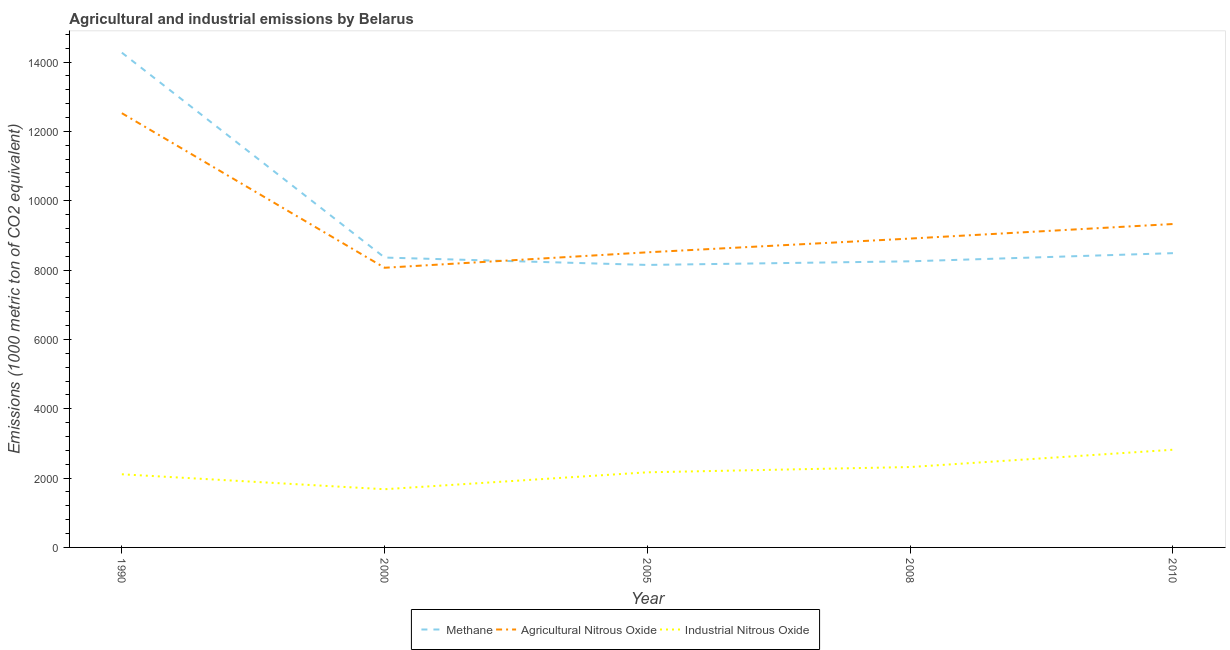What is the amount of industrial nitrous oxide emissions in 2010?
Your answer should be very brief. 2817.5. Across all years, what is the maximum amount of methane emissions?
Offer a terse response. 1.43e+04. Across all years, what is the minimum amount of agricultural nitrous oxide emissions?
Provide a succinct answer. 8066.2. In which year was the amount of methane emissions maximum?
Give a very brief answer. 1990. In which year was the amount of industrial nitrous oxide emissions minimum?
Your answer should be very brief. 2000. What is the total amount of methane emissions in the graph?
Your response must be concise. 4.75e+04. What is the difference between the amount of industrial nitrous oxide emissions in 1990 and that in 2010?
Your answer should be compact. -707.9. What is the difference between the amount of industrial nitrous oxide emissions in 2010 and the amount of agricultural nitrous oxide emissions in 2008?
Ensure brevity in your answer.  -6090.9. What is the average amount of agricultural nitrous oxide emissions per year?
Your answer should be very brief. 9467.8. In the year 2010, what is the difference between the amount of industrial nitrous oxide emissions and amount of agricultural nitrous oxide emissions?
Provide a succinct answer. -6510.4. In how many years, is the amount of methane emissions greater than 12800 metric ton?
Your response must be concise. 1. What is the ratio of the amount of methane emissions in 1990 to that in 2000?
Provide a succinct answer. 1.71. What is the difference between the highest and the second highest amount of agricultural nitrous oxide emissions?
Make the answer very short. 3196.7. What is the difference between the highest and the lowest amount of agricultural nitrous oxide emissions?
Make the answer very short. 4458.4. Is it the case that in every year, the sum of the amount of methane emissions and amount of agricultural nitrous oxide emissions is greater than the amount of industrial nitrous oxide emissions?
Offer a terse response. Yes. Does the amount of methane emissions monotonically increase over the years?
Offer a terse response. No. How many lines are there?
Your answer should be compact. 3. How many years are there in the graph?
Give a very brief answer. 5. What is the difference between two consecutive major ticks on the Y-axis?
Provide a short and direct response. 2000. Are the values on the major ticks of Y-axis written in scientific E-notation?
Your response must be concise. No. Does the graph contain any zero values?
Your response must be concise. No. How many legend labels are there?
Provide a short and direct response. 3. How are the legend labels stacked?
Give a very brief answer. Horizontal. What is the title of the graph?
Keep it short and to the point. Agricultural and industrial emissions by Belarus. Does "Textiles and clothing" appear as one of the legend labels in the graph?
Make the answer very short. No. What is the label or title of the X-axis?
Keep it short and to the point. Year. What is the label or title of the Y-axis?
Your answer should be compact. Emissions (1000 metric ton of CO2 equivalent). What is the Emissions (1000 metric ton of CO2 equivalent) of Methane in 1990?
Make the answer very short. 1.43e+04. What is the Emissions (1000 metric ton of CO2 equivalent) in Agricultural Nitrous Oxide in 1990?
Keep it short and to the point. 1.25e+04. What is the Emissions (1000 metric ton of CO2 equivalent) of Industrial Nitrous Oxide in 1990?
Give a very brief answer. 2109.6. What is the Emissions (1000 metric ton of CO2 equivalent) of Methane in 2000?
Provide a short and direct response. 8360.4. What is the Emissions (1000 metric ton of CO2 equivalent) in Agricultural Nitrous Oxide in 2000?
Ensure brevity in your answer.  8066.2. What is the Emissions (1000 metric ton of CO2 equivalent) in Industrial Nitrous Oxide in 2000?
Ensure brevity in your answer.  1678.6. What is the Emissions (1000 metric ton of CO2 equivalent) in Methane in 2005?
Ensure brevity in your answer.  8147.7. What is the Emissions (1000 metric ton of CO2 equivalent) of Agricultural Nitrous Oxide in 2005?
Ensure brevity in your answer.  8511.9. What is the Emissions (1000 metric ton of CO2 equivalent) in Industrial Nitrous Oxide in 2005?
Give a very brief answer. 2166.7. What is the Emissions (1000 metric ton of CO2 equivalent) of Methane in 2008?
Give a very brief answer. 8252. What is the Emissions (1000 metric ton of CO2 equivalent) of Agricultural Nitrous Oxide in 2008?
Keep it short and to the point. 8908.4. What is the Emissions (1000 metric ton of CO2 equivalent) of Industrial Nitrous Oxide in 2008?
Your response must be concise. 2318.7. What is the Emissions (1000 metric ton of CO2 equivalent) of Methane in 2010?
Offer a terse response. 8487.5. What is the Emissions (1000 metric ton of CO2 equivalent) of Agricultural Nitrous Oxide in 2010?
Offer a very short reply. 9327.9. What is the Emissions (1000 metric ton of CO2 equivalent) of Industrial Nitrous Oxide in 2010?
Provide a short and direct response. 2817.5. Across all years, what is the maximum Emissions (1000 metric ton of CO2 equivalent) of Methane?
Your answer should be compact. 1.43e+04. Across all years, what is the maximum Emissions (1000 metric ton of CO2 equivalent) of Agricultural Nitrous Oxide?
Make the answer very short. 1.25e+04. Across all years, what is the maximum Emissions (1000 metric ton of CO2 equivalent) in Industrial Nitrous Oxide?
Offer a terse response. 2817.5. Across all years, what is the minimum Emissions (1000 metric ton of CO2 equivalent) in Methane?
Offer a terse response. 8147.7. Across all years, what is the minimum Emissions (1000 metric ton of CO2 equivalent) of Agricultural Nitrous Oxide?
Give a very brief answer. 8066.2. Across all years, what is the minimum Emissions (1000 metric ton of CO2 equivalent) in Industrial Nitrous Oxide?
Your answer should be compact. 1678.6. What is the total Emissions (1000 metric ton of CO2 equivalent) in Methane in the graph?
Your answer should be compact. 4.75e+04. What is the total Emissions (1000 metric ton of CO2 equivalent) in Agricultural Nitrous Oxide in the graph?
Your answer should be very brief. 4.73e+04. What is the total Emissions (1000 metric ton of CO2 equivalent) in Industrial Nitrous Oxide in the graph?
Make the answer very short. 1.11e+04. What is the difference between the Emissions (1000 metric ton of CO2 equivalent) of Methane in 1990 and that in 2000?
Your answer should be compact. 5909.9. What is the difference between the Emissions (1000 metric ton of CO2 equivalent) in Agricultural Nitrous Oxide in 1990 and that in 2000?
Offer a very short reply. 4458.4. What is the difference between the Emissions (1000 metric ton of CO2 equivalent) of Industrial Nitrous Oxide in 1990 and that in 2000?
Offer a terse response. 431. What is the difference between the Emissions (1000 metric ton of CO2 equivalent) of Methane in 1990 and that in 2005?
Provide a short and direct response. 6122.6. What is the difference between the Emissions (1000 metric ton of CO2 equivalent) of Agricultural Nitrous Oxide in 1990 and that in 2005?
Keep it short and to the point. 4012.7. What is the difference between the Emissions (1000 metric ton of CO2 equivalent) in Industrial Nitrous Oxide in 1990 and that in 2005?
Make the answer very short. -57.1. What is the difference between the Emissions (1000 metric ton of CO2 equivalent) of Methane in 1990 and that in 2008?
Your response must be concise. 6018.3. What is the difference between the Emissions (1000 metric ton of CO2 equivalent) in Agricultural Nitrous Oxide in 1990 and that in 2008?
Offer a terse response. 3616.2. What is the difference between the Emissions (1000 metric ton of CO2 equivalent) in Industrial Nitrous Oxide in 1990 and that in 2008?
Give a very brief answer. -209.1. What is the difference between the Emissions (1000 metric ton of CO2 equivalent) in Methane in 1990 and that in 2010?
Provide a succinct answer. 5782.8. What is the difference between the Emissions (1000 metric ton of CO2 equivalent) in Agricultural Nitrous Oxide in 1990 and that in 2010?
Offer a terse response. 3196.7. What is the difference between the Emissions (1000 metric ton of CO2 equivalent) in Industrial Nitrous Oxide in 1990 and that in 2010?
Keep it short and to the point. -707.9. What is the difference between the Emissions (1000 metric ton of CO2 equivalent) of Methane in 2000 and that in 2005?
Make the answer very short. 212.7. What is the difference between the Emissions (1000 metric ton of CO2 equivalent) of Agricultural Nitrous Oxide in 2000 and that in 2005?
Keep it short and to the point. -445.7. What is the difference between the Emissions (1000 metric ton of CO2 equivalent) in Industrial Nitrous Oxide in 2000 and that in 2005?
Give a very brief answer. -488.1. What is the difference between the Emissions (1000 metric ton of CO2 equivalent) of Methane in 2000 and that in 2008?
Keep it short and to the point. 108.4. What is the difference between the Emissions (1000 metric ton of CO2 equivalent) of Agricultural Nitrous Oxide in 2000 and that in 2008?
Keep it short and to the point. -842.2. What is the difference between the Emissions (1000 metric ton of CO2 equivalent) of Industrial Nitrous Oxide in 2000 and that in 2008?
Give a very brief answer. -640.1. What is the difference between the Emissions (1000 metric ton of CO2 equivalent) of Methane in 2000 and that in 2010?
Offer a terse response. -127.1. What is the difference between the Emissions (1000 metric ton of CO2 equivalent) of Agricultural Nitrous Oxide in 2000 and that in 2010?
Keep it short and to the point. -1261.7. What is the difference between the Emissions (1000 metric ton of CO2 equivalent) in Industrial Nitrous Oxide in 2000 and that in 2010?
Provide a succinct answer. -1138.9. What is the difference between the Emissions (1000 metric ton of CO2 equivalent) of Methane in 2005 and that in 2008?
Your answer should be very brief. -104.3. What is the difference between the Emissions (1000 metric ton of CO2 equivalent) in Agricultural Nitrous Oxide in 2005 and that in 2008?
Your response must be concise. -396.5. What is the difference between the Emissions (1000 metric ton of CO2 equivalent) in Industrial Nitrous Oxide in 2005 and that in 2008?
Give a very brief answer. -152. What is the difference between the Emissions (1000 metric ton of CO2 equivalent) of Methane in 2005 and that in 2010?
Offer a terse response. -339.8. What is the difference between the Emissions (1000 metric ton of CO2 equivalent) in Agricultural Nitrous Oxide in 2005 and that in 2010?
Provide a short and direct response. -816. What is the difference between the Emissions (1000 metric ton of CO2 equivalent) of Industrial Nitrous Oxide in 2005 and that in 2010?
Offer a terse response. -650.8. What is the difference between the Emissions (1000 metric ton of CO2 equivalent) in Methane in 2008 and that in 2010?
Your answer should be compact. -235.5. What is the difference between the Emissions (1000 metric ton of CO2 equivalent) in Agricultural Nitrous Oxide in 2008 and that in 2010?
Offer a terse response. -419.5. What is the difference between the Emissions (1000 metric ton of CO2 equivalent) of Industrial Nitrous Oxide in 2008 and that in 2010?
Offer a very short reply. -498.8. What is the difference between the Emissions (1000 metric ton of CO2 equivalent) of Methane in 1990 and the Emissions (1000 metric ton of CO2 equivalent) of Agricultural Nitrous Oxide in 2000?
Keep it short and to the point. 6204.1. What is the difference between the Emissions (1000 metric ton of CO2 equivalent) of Methane in 1990 and the Emissions (1000 metric ton of CO2 equivalent) of Industrial Nitrous Oxide in 2000?
Provide a short and direct response. 1.26e+04. What is the difference between the Emissions (1000 metric ton of CO2 equivalent) in Agricultural Nitrous Oxide in 1990 and the Emissions (1000 metric ton of CO2 equivalent) in Industrial Nitrous Oxide in 2000?
Make the answer very short. 1.08e+04. What is the difference between the Emissions (1000 metric ton of CO2 equivalent) of Methane in 1990 and the Emissions (1000 metric ton of CO2 equivalent) of Agricultural Nitrous Oxide in 2005?
Ensure brevity in your answer.  5758.4. What is the difference between the Emissions (1000 metric ton of CO2 equivalent) of Methane in 1990 and the Emissions (1000 metric ton of CO2 equivalent) of Industrial Nitrous Oxide in 2005?
Offer a terse response. 1.21e+04. What is the difference between the Emissions (1000 metric ton of CO2 equivalent) of Agricultural Nitrous Oxide in 1990 and the Emissions (1000 metric ton of CO2 equivalent) of Industrial Nitrous Oxide in 2005?
Offer a very short reply. 1.04e+04. What is the difference between the Emissions (1000 metric ton of CO2 equivalent) in Methane in 1990 and the Emissions (1000 metric ton of CO2 equivalent) in Agricultural Nitrous Oxide in 2008?
Provide a short and direct response. 5361.9. What is the difference between the Emissions (1000 metric ton of CO2 equivalent) in Methane in 1990 and the Emissions (1000 metric ton of CO2 equivalent) in Industrial Nitrous Oxide in 2008?
Offer a very short reply. 1.20e+04. What is the difference between the Emissions (1000 metric ton of CO2 equivalent) in Agricultural Nitrous Oxide in 1990 and the Emissions (1000 metric ton of CO2 equivalent) in Industrial Nitrous Oxide in 2008?
Your response must be concise. 1.02e+04. What is the difference between the Emissions (1000 metric ton of CO2 equivalent) in Methane in 1990 and the Emissions (1000 metric ton of CO2 equivalent) in Agricultural Nitrous Oxide in 2010?
Offer a very short reply. 4942.4. What is the difference between the Emissions (1000 metric ton of CO2 equivalent) of Methane in 1990 and the Emissions (1000 metric ton of CO2 equivalent) of Industrial Nitrous Oxide in 2010?
Offer a very short reply. 1.15e+04. What is the difference between the Emissions (1000 metric ton of CO2 equivalent) of Agricultural Nitrous Oxide in 1990 and the Emissions (1000 metric ton of CO2 equivalent) of Industrial Nitrous Oxide in 2010?
Your answer should be very brief. 9707.1. What is the difference between the Emissions (1000 metric ton of CO2 equivalent) in Methane in 2000 and the Emissions (1000 metric ton of CO2 equivalent) in Agricultural Nitrous Oxide in 2005?
Offer a terse response. -151.5. What is the difference between the Emissions (1000 metric ton of CO2 equivalent) of Methane in 2000 and the Emissions (1000 metric ton of CO2 equivalent) of Industrial Nitrous Oxide in 2005?
Give a very brief answer. 6193.7. What is the difference between the Emissions (1000 metric ton of CO2 equivalent) in Agricultural Nitrous Oxide in 2000 and the Emissions (1000 metric ton of CO2 equivalent) in Industrial Nitrous Oxide in 2005?
Offer a very short reply. 5899.5. What is the difference between the Emissions (1000 metric ton of CO2 equivalent) of Methane in 2000 and the Emissions (1000 metric ton of CO2 equivalent) of Agricultural Nitrous Oxide in 2008?
Give a very brief answer. -548. What is the difference between the Emissions (1000 metric ton of CO2 equivalent) of Methane in 2000 and the Emissions (1000 metric ton of CO2 equivalent) of Industrial Nitrous Oxide in 2008?
Keep it short and to the point. 6041.7. What is the difference between the Emissions (1000 metric ton of CO2 equivalent) of Agricultural Nitrous Oxide in 2000 and the Emissions (1000 metric ton of CO2 equivalent) of Industrial Nitrous Oxide in 2008?
Your answer should be very brief. 5747.5. What is the difference between the Emissions (1000 metric ton of CO2 equivalent) of Methane in 2000 and the Emissions (1000 metric ton of CO2 equivalent) of Agricultural Nitrous Oxide in 2010?
Your response must be concise. -967.5. What is the difference between the Emissions (1000 metric ton of CO2 equivalent) in Methane in 2000 and the Emissions (1000 metric ton of CO2 equivalent) in Industrial Nitrous Oxide in 2010?
Offer a very short reply. 5542.9. What is the difference between the Emissions (1000 metric ton of CO2 equivalent) in Agricultural Nitrous Oxide in 2000 and the Emissions (1000 metric ton of CO2 equivalent) in Industrial Nitrous Oxide in 2010?
Your answer should be very brief. 5248.7. What is the difference between the Emissions (1000 metric ton of CO2 equivalent) of Methane in 2005 and the Emissions (1000 metric ton of CO2 equivalent) of Agricultural Nitrous Oxide in 2008?
Your answer should be compact. -760.7. What is the difference between the Emissions (1000 metric ton of CO2 equivalent) of Methane in 2005 and the Emissions (1000 metric ton of CO2 equivalent) of Industrial Nitrous Oxide in 2008?
Your answer should be compact. 5829. What is the difference between the Emissions (1000 metric ton of CO2 equivalent) in Agricultural Nitrous Oxide in 2005 and the Emissions (1000 metric ton of CO2 equivalent) in Industrial Nitrous Oxide in 2008?
Offer a terse response. 6193.2. What is the difference between the Emissions (1000 metric ton of CO2 equivalent) in Methane in 2005 and the Emissions (1000 metric ton of CO2 equivalent) in Agricultural Nitrous Oxide in 2010?
Offer a terse response. -1180.2. What is the difference between the Emissions (1000 metric ton of CO2 equivalent) of Methane in 2005 and the Emissions (1000 metric ton of CO2 equivalent) of Industrial Nitrous Oxide in 2010?
Offer a very short reply. 5330.2. What is the difference between the Emissions (1000 metric ton of CO2 equivalent) in Agricultural Nitrous Oxide in 2005 and the Emissions (1000 metric ton of CO2 equivalent) in Industrial Nitrous Oxide in 2010?
Make the answer very short. 5694.4. What is the difference between the Emissions (1000 metric ton of CO2 equivalent) in Methane in 2008 and the Emissions (1000 metric ton of CO2 equivalent) in Agricultural Nitrous Oxide in 2010?
Provide a succinct answer. -1075.9. What is the difference between the Emissions (1000 metric ton of CO2 equivalent) in Methane in 2008 and the Emissions (1000 metric ton of CO2 equivalent) in Industrial Nitrous Oxide in 2010?
Give a very brief answer. 5434.5. What is the difference between the Emissions (1000 metric ton of CO2 equivalent) in Agricultural Nitrous Oxide in 2008 and the Emissions (1000 metric ton of CO2 equivalent) in Industrial Nitrous Oxide in 2010?
Your response must be concise. 6090.9. What is the average Emissions (1000 metric ton of CO2 equivalent) of Methane per year?
Ensure brevity in your answer.  9503.58. What is the average Emissions (1000 metric ton of CO2 equivalent) of Agricultural Nitrous Oxide per year?
Your answer should be very brief. 9467.8. What is the average Emissions (1000 metric ton of CO2 equivalent) of Industrial Nitrous Oxide per year?
Provide a succinct answer. 2218.22. In the year 1990, what is the difference between the Emissions (1000 metric ton of CO2 equivalent) in Methane and Emissions (1000 metric ton of CO2 equivalent) in Agricultural Nitrous Oxide?
Provide a short and direct response. 1745.7. In the year 1990, what is the difference between the Emissions (1000 metric ton of CO2 equivalent) in Methane and Emissions (1000 metric ton of CO2 equivalent) in Industrial Nitrous Oxide?
Keep it short and to the point. 1.22e+04. In the year 1990, what is the difference between the Emissions (1000 metric ton of CO2 equivalent) in Agricultural Nitrous Oxide and Emissions (1000 metric ton of CO2 equivalent) in Industrial Nitrous Oxide?
Provide a short and direct response. 1.04e+04. In the year 2000, what is the difference between the Emissions (1000 metric ton of CO2 equivalent) in Methane and Emissions (1000 metric ton of CO2 equivalent) in Agricultural Nitrous Oxide?
Ensure brevity in your answer.  294.2. In the year 2000, what is the difference between the Emissions (1000 metric ton of CO2 equivalent) in Methane and Emissions (1000 metric ton of CO2 equivalent) in Industrial Nitrous Oxide?
Offer a very short reply. 6681.8. In the year 2000, what is the difference between the Emissions (1000 metric ton of CO2 equivalent) of Agricultural Nitrous Oxide and Emissions (1000 metric ton of CO2 equivalent) of Industrial Nitrous Oxide?
Your response must be concise. 6387.6. In the year 2005, what is the difference between the Emissions (1000 metric ton of CO2 equivalent) of Methane and Emissions (1000 metric ton of CO2 equivalent) of Agricultural Nitrous Oxide?
Your answer should be compact. -364.2. In the year 2005, what is the difference between the Emissions (1000 metric ton of CO2 equivalent) of Methane and Emissions (1000 metric ton of CO2 equivalent) of Industrial Nitrous Oxide?
Offer a terse response. 5981. In the year 2005, what is the difference between the Emissions (1000 metric ton of CO2 equivalent) of Agricultural Nitrous Oxide and Emissions (1000 metric ton of CO2 equivalent) of Industrial Nitrous Oxide?
Your answer should be very brief. 6345.2. In the year 2008, what is the difference between the Emissions (1000 metric ton of CO2 equivalent) of Methane and Emissions (1000 metric ton of CO2 equivalent) of Agricultural Nitrous Oxide?
Your answer should be compact. -656.4. In the year 2008, what is the difference between the Emissions (1000 metric ton of CO2 equivalent) in Methane and Emissions (1000 metric ton of CO2 equivalent) in Industrial Nitrous Oxide?
Provide a short and direct response. 5933.3. In the year 2008, what is the difference between the Emissions (1000 metric ton of CO2 equivalent) in Agricultural Nitrous Oxide and Emissions (1000 metric ton of CO2 equivalent) in Industrial Nitrous Oxide?
Your response must be concise. 6589.7. In the year 2010, what is the difference between the Emissions (1000 metric ton of CO2 equivalent) of Methane and Emissions (1000 metric ton of CO2 equivalent) of Agricultural Nitrous Oxide?
Your answer should be compact. -840.4. In the year 2010, what is the difference between the Emissions (1000 metric ton of CO2 equivalent) of Methane and Emissions (1000 metric ton of CO2 equivalent) of Industrial Nitrous Oxide?
Provide a succinct answer. 5670. In the year 2010, what is the difference between the Emissions (1000 metric ton of CO2 equivalent) of Agricultural Nitrous Oxide and Emissions (1000 metric ton of CO2 equivalent) of Industrial Nitrous Oxide?
Keep it short and to the point. 6510.4. What is the ratio of the Emissions (1000 metric ton of CO2 equivalent) of Methane in 1990 to that in 2000?
Provide a succinct answer. 1.71. What is the ratio of the Emissions (1000 metric ton of CO2 equivalent) of Agricultural Nitrous Oxide in 1990 to that in 2000?
Make the answer very short. 1.55. What is the ratio of the Emissions (1000 metric ton of CO2 equivalent) in Industrial Nitrous Oxide in 1990 to that in 2000?
Offer a terse response. 1.26. What is the ratio of the Emissions (1000 metric ton of CO2 equivalent) of Methane in 1990 to that in 2005?
Your answer should be compact. 1.75. What is the ratio of the Emissions (1000 metric ton of CO2 equivalent) of Agricultural Nitrous Oxide in 1990 to that in 2005?
Give a very brief answer. 1.47. What is the ratio of the Emissions (1000 metric ton of CO2 equivalent) in Industrial Nitrous Oxide in 1990 to that in 2005?
Offer a very short reply. 0.97. What is the ratio of the Emissions (1000 metric ton of CO2 equivalent) of Methane in 1990 to that in 2008?
Ensure brevity in your answer.  1.73. What is the ratio of the Emissions (1000 metric ton of CO2 equivalent) of Agricultural Nitrous Oxide in 1990 to that in 2008?
Provide a succinct answer. 1.41. What is the ratio of the Emissions (1000 metric ton of CO2 equivalent) of Industrial Nitrous Oxide in 1990 to that in 2008?
Keep it short and to the point. 0.91. What is the ratio of the Emissions (1000 metric ton of CO2 equivalent) in Methane in 1990 to that in 2010?
Offer a terse response. 1.68. What is the ratio of the Emissions (1000 metric ton of CO2 equivalent) of Agricultural Nitrous Oxide in 1990 to that in 2010?
Your answer should be compact. 1.34. What is the ratio of the Emissions (1000 metric ton of CO2 equivalent) of Industrial Nitrous Oxide in 1990 to that in 2010?
Your response must be concise. 0.75. What is the ratio of the Emissions (1000 metric ton of CO2 equivalent) of Methane in 2000 to that in 2005?
Offer a terse response. 1.03. What is the ratio of the Emissions (1000 metric ton of CO2 equivalent) in Agricultural Nitrous Oxide in 2000 to that in 2005?
Ensure brevity in your answer.  0.95. What is the ratio of the Emissions (1000 metric ton of CO2 equivalent) of Industrial Nitrous Oxide in 2000 to that in 2005?
Keep it short and to the point. 0.77. What is the ratio of the Emissions (1000 metric ton of CO2 equivalent) in Methane in 2000 to that in 2008?
Your response must be concise. 1.01. What is the ratio of the Emissions (1000 metric ton of CO2 equivalent) in Agricultural Nitrous Oxide in 2000 to that in 2008?
Ensure brevity in your answer.  0.91. What is the ratio of the Emissions (1000 metric ton of CO2 equivalent) of Industrial Nitrous Oxide in 2000 to that in 2008?
Provide a succinct answer. 0.72. What is the ratio of the Emissions (1000 metric ton of CO2 equivalent) in Methane in 2000 to that in 2010?
Your response must be concise. 0.98. What is the ratio of the Emissions (1000 metric ton of CO2 equivalent) of Agricultural Nitrous Oxide in 2000 to that in 2010?
Provide a succinct answer. 0.86. What is the ratio of the Emissions (1000 metric ton of CO2 equivalent) in Industrial Nitrous Oxide in 2000 to that in 2010?
Keep it short and to the point. 0.6. What is the ratio of the Emissions (1000 metric ton of CO2 equivalent) in Methane in 2005 to that in 2008?
Offer a very short reply. 0.99. What is the ratio of the Emissions (1000 metric ton of CO2 equivalent) of Agricultural Nitrous Oxide in 2005 to that in 2008?
Keep it short and to the point. 0.96. What is the ratio of the Emissions (1000 metric ton of CO2 equivalent) of Industrial Nitrous Oxide in 2005 to that in 2008?
Offer a terse response. 0.93. What is the ratio of the Emissions (1000 metric ton of CO2 equivalent) of Methane in 2005 to that in 2010?
Provide a short and direct response. 0.96. What is the ratio of the Emissions (1000 metric ton of CO2 equivalent) in Agricultural Nitrous Oxide in 2005 to that in 2010?
Provide a short and direct response. 0.91. What is the ratio of the Emissions (1000 metric ton of CO2 equivalent) in Industrial Nitrous Oxide in 2005 to that in 2010?
Provide a succinct answer. 0.77. What is the ratio of the Emissions (1000 metric ton of CO2 equivalent) in Methane in 2008 to that in 2010?
Provide a succinct answer. 0.97. What is the ratio of the Emissions (1000 metric ton of CO2 equivalent) in Agricultural Nitrous Oxide in 2008 to that in 2010?
Give a very brief answer. 0.95. What is the ratio of the Emissions (1000 metric ton of CO2 equivalent) in Industrial Nitrous Oxide in 2008 to that in 2010?
Provide a short and direct response. 0.82. What is the difference between the highest and the second highest Emissions (1000 metric ton of CO2 equivalent) in Methane?
Give a very brief answer. 5782.8. What is the difference between the highest and the second highest Emissions (1000 metric ton of CO2 equivalent) in Agricultural Nitrous Oxide?
Offer a very short reply. 3196.7. What is the difference between the highest and the second highest Emissions (1000 metric ton of CO2 equivalent) in Industrial Nitrous Oxide?
Ensure brevity in your answer.  498.8. What is the difference between the highest and the lowest Emissions (1000 metric ton of CO2 equivalent) in Methane?
Your answer should be compact. 6122.6. What is the difference between the highest and the lowest Emissions (1000 metric ton of CO2 equivalent) of Agricultural Nitrous Oxide?
Offer a terse response. 4458.4. What is the difference between the highest and the lowest Emissions (1000 metric ton of CO2 equivalent) of Industrial Nitrous Oxide?
Offer a terse response. 1138.9. 